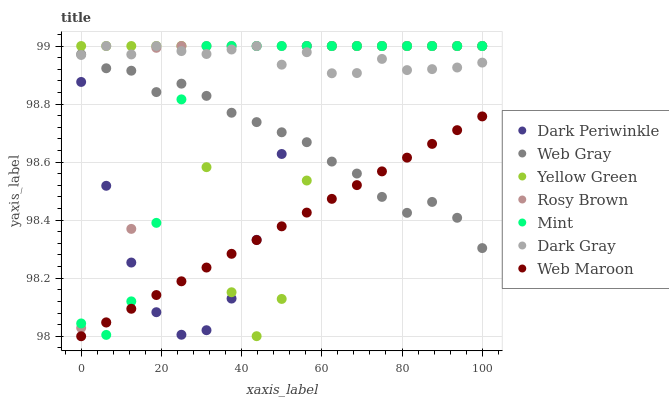Does Web Maroon have the minimum area under the curve?
Answer yes or no. Yes. Does Dark Gray have the maximum area under the curve?
Answer yes or no. Yes. Does Yellow Green have the minimum area under the curve?
Answer yes or no. No. Does Yellow Green have the maximum area under the curve?
Answer yes or no. No. Is Web Maroon the smoothest?
Answer yes or no. Yes. Is Yellow Green the roughest?
Answer yes or no. Yes. Is Rosy Brown the smoothest?
Answer yes or no. No. Is Rosy Brown the roughest?
Answer yes or no. No. Does Web Maroon have the lowest value?
Answer yes or no. Yes. Does Yellow Green have the lowest value?
Answer yes or no. No. Does Dark Periwinkle have the highest value?
Answer yes or no. Yes. Does Web Maroon have the highest value?
Answer yes or no. No. Is Web Maroon less than Rosy Brown?
Answer yes or no. Yes. Is Rosy Brown greater than Web Maroon?
Answer yes or no. Yes. Does Dark Gray intersect Yellow Green?
Answer yes or no. Yes. Is Dark Gray less than Yellow Green?
Answer yes or no. No. Is Dark Gray greater than Yellow Green?
Answer yes or no. No. Does Web Maroon intersect Rosy Brown?
Answer yes or no. No. 